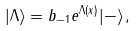<formula> <loc_0><loc_0><loc_500><loc_500>| \Lambda \rangle = b _ { - 1 } e ^ { \Lambda ( x ) } | - \rangle \, ,</formula> 